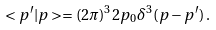Convert formula to latex. <formula><loc_0><loc_0><loc_500><loc_500>< p ^ { \prime } | p > = ( 2 \pi ) ^ { 3 } 2 p _ { 0 } \delta ^ { 3 } ( { p } - { p } ^ { \prime } ) \, .</formula> 